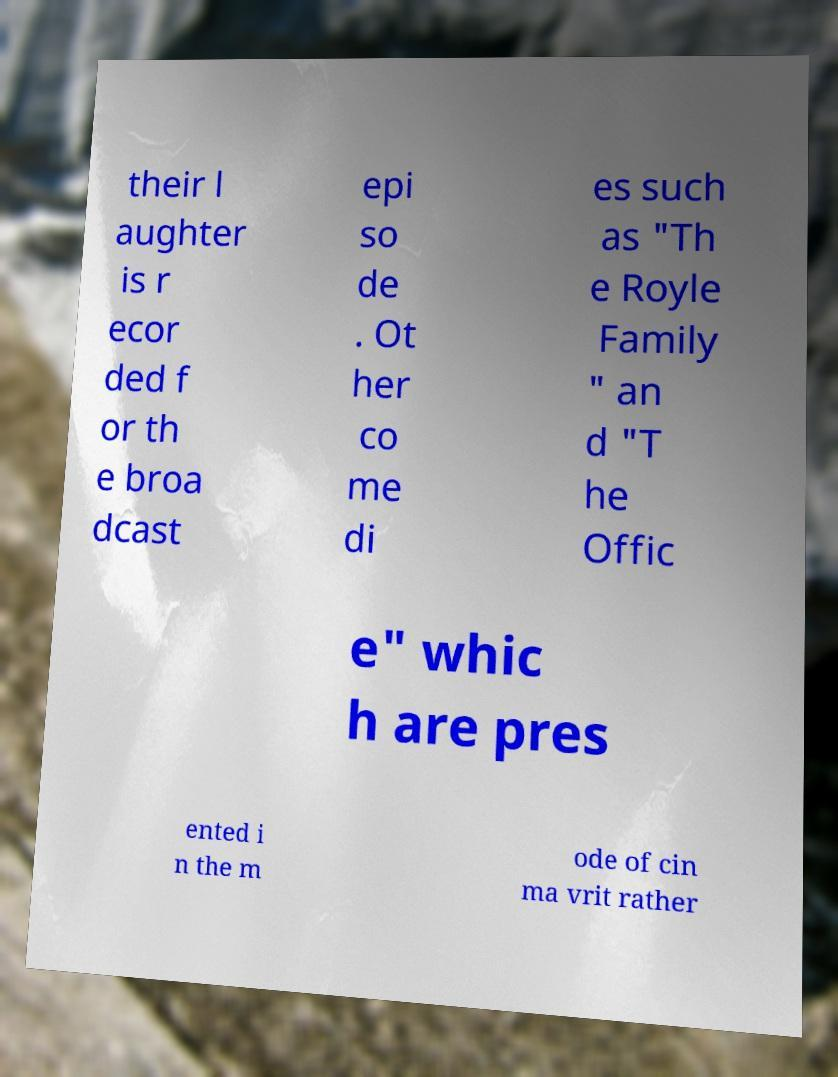Please identify and transcribe the text found in this image. their l aughter is r ecor ded f or th e broa dcast epi so de . Ot her co me di es such as "Th e Royle Family " an d "T he Offic e" whic h are pres ented i n the m ode of cin ma vrit rather 